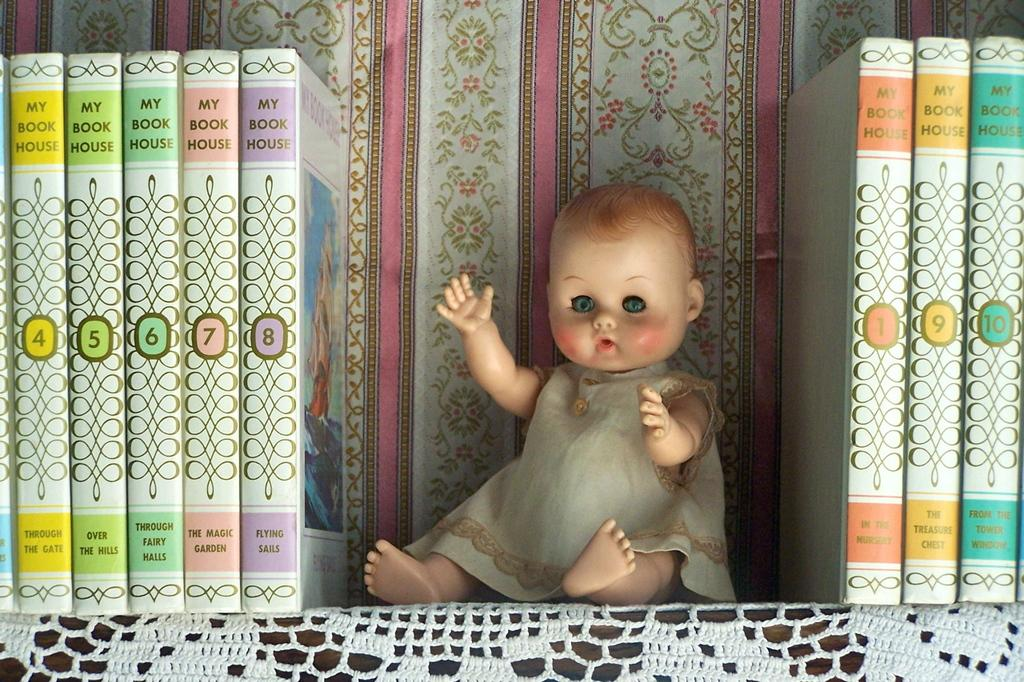<image>
Render a clear and concise summary of the photo. A book shelf with a doll and books from the series My Book House. 